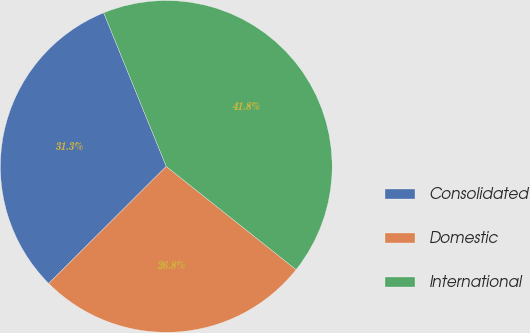Convert chart to OTSL. <chart><loc_0><loc_0><loc_500><loc_500><pie_chart><fcel>Consolidated<fcel>Domestic<fcel>International<nl><fcel>31.31%<fcel>26.84%<fcel>41.85%<nl></chart> 